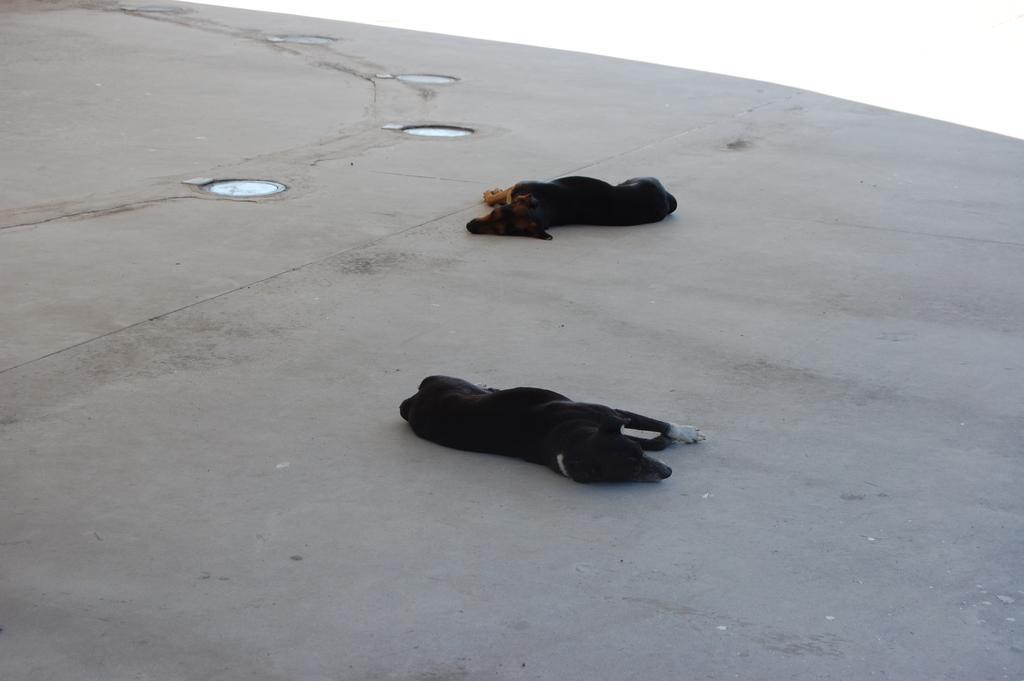Describe this image in one or two sentences. In the picture I can see two black color dogs are lying on the ground. I can also see some other objects on the ground. The background of the image is white in color. 